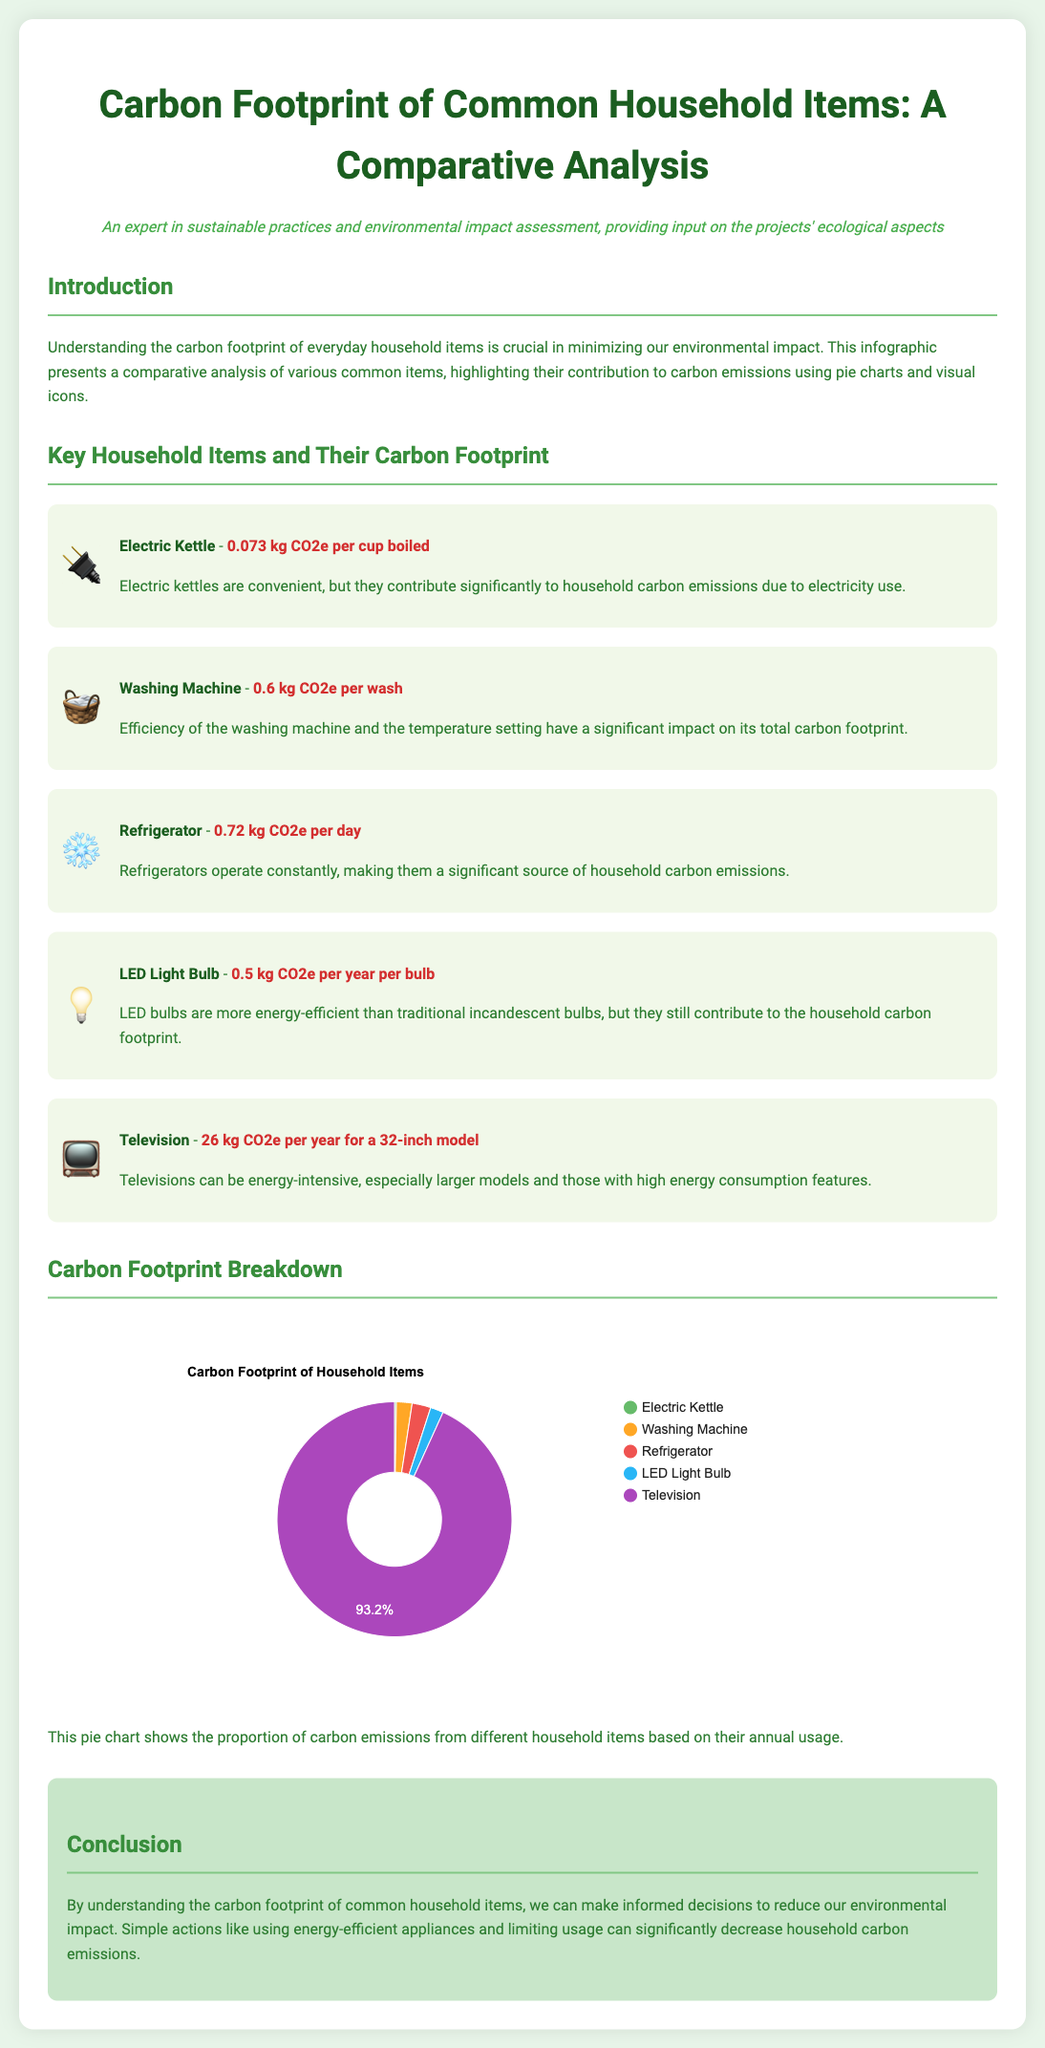what is the carbon footprint of an electric kettle? The carbon footprint for an electric kettle is provided in the document, which states it is 0.073 kg CO2e per cup boiled.
Answer: 0.073 kg CO2e per cup boiled what is the annual carbon footprint of a television? The document clearly mentions that the annual carbon footprint of a 32-inch television is 26 kg CO2e.
Answer: 26 kg CO2e per year which item has the highest carbon footprint? By comparing the values mentioned for each item in the document, the television has the highest carbon footprint.
Answer: Television what is the carbon footprint of a washing machine? The washing machine's carbon footprint is specified in the document as 0.6 kg CO2e per wash.
Answer: 0.6 kg CO2e per wash how does the carbon footprint of LED light bulbs compare to that of a refrigerator? To answer this, one needs to compare the carbon footprints mentioned: 0.5 kg CO2e per year for LED bulbs and 0.72 kg CO2e per day for refrigerators.
Answer: LED light bulbs have a lower carbon footprint what does the pie chart represent? The pie chart shows the proportion of carbon emissions from different household items based on their annual usage as mentioned in the document.
Answer: Proportion of carbon emissions from household items what are the ecological practices suggested in the conclusion? The conclusion states that using energy-efficient appliances and limiting usage can help reduce household carbon emissions.
Answer: Use energy-efficient appliances and limit usage 